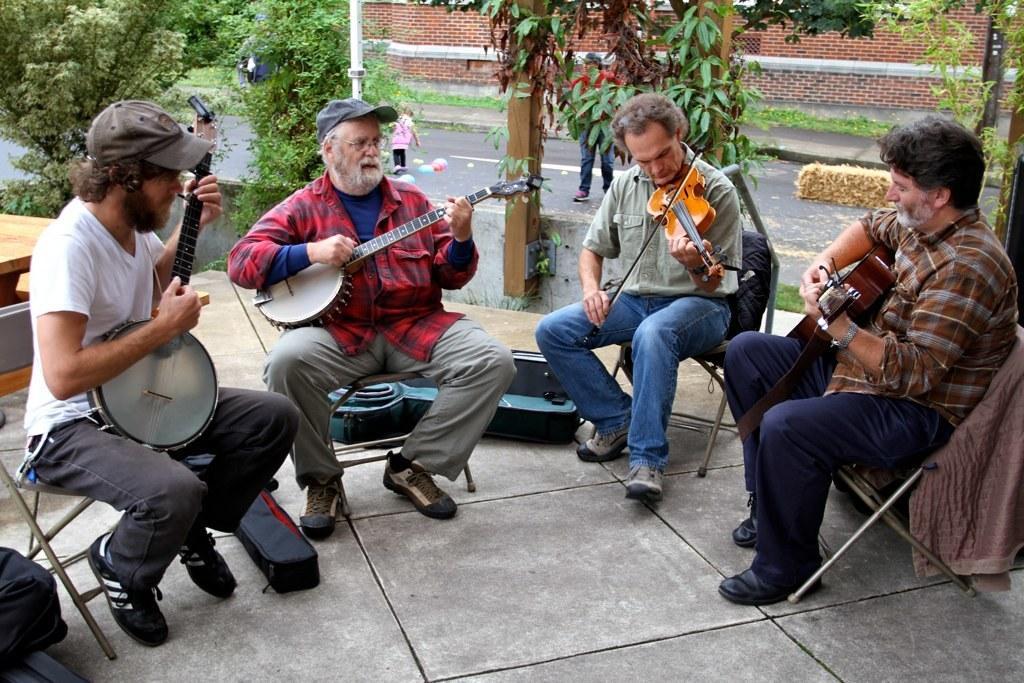Please provide a concise description of this image. In this image there are four persons who are sitting on a chair. On the right side the person who is sitting and he is playing guitar, beside him the person who is sitting and he is playing a violin and beside him the person who is sitting and he is playing banjo and on the left side the person who is sitting and he is also playing a banjo. On the background there are trees and one house is there. 